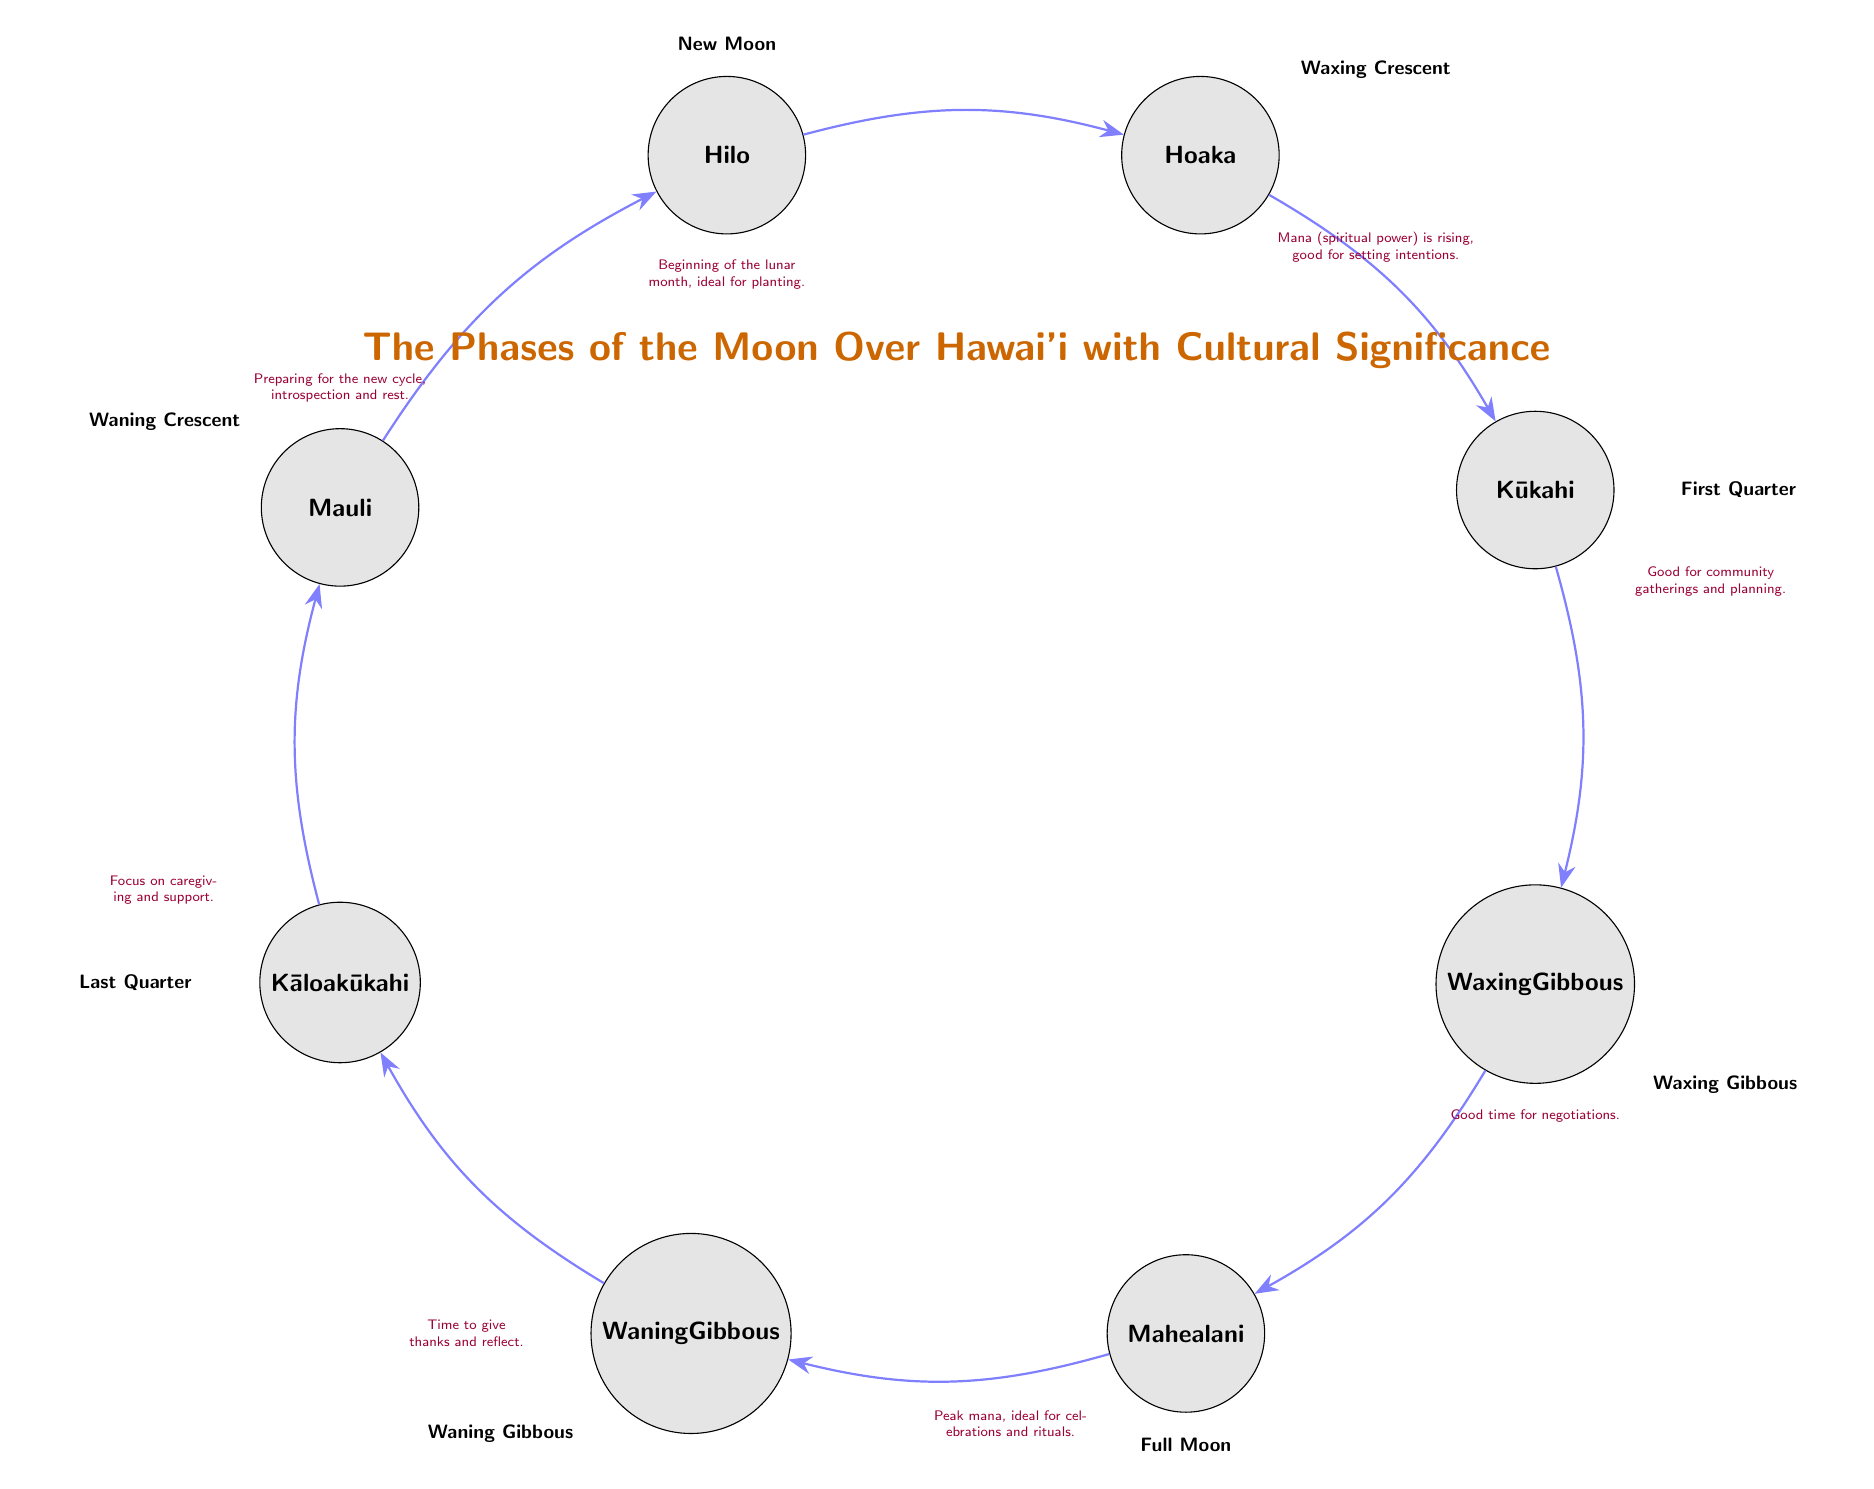What is the first phase of the moon shown in the diagram? The diagram indicates that the first phase is marked as "New Moon." This is the starting point of the phases.
Answer: New Moon Which phase is associated with the term "Mahealani"? The term "Mahealani" is used to represent the Full Moon phase according to the diagram.
Answer: Full Moon What is the second phase of the moon? According to the diagram, the second phase following the New Moon is the Waxing Crescent.
Answer: Waxing Crescent How many phases of the moon are illustrated in the diagram? The diagram illustrates a total of eight phases, including the descriptions provided for each.
Answer: Eight Which phase should one focus on for caregiving and support? The diagram indicates that the Last Quarter phase is designated for caregiving and support, making it the appropriate choice.
Answer: Last Quarter Where does the "Waning Crescent" fall in the order of the moon phases? The Waning Crescent is the last phase before returning to the New Moon, which makes it the eighth phase in the sequence.
Answer: Eighth What cultural aspect is highlighted during the Full Moon phase? The diagram points out that the Full Moon phase is associated with peak mana and is ideal for celebrations and rituals, reflecting cultural significance.
Answer: Peak mana, celebrations, rituals During which phase is it considered a good time for negotiations? According to the diagram, the Waxing Gibbous phase is the time indicated for negotiations, making it the relevant phase for this purpose.
Answer: Waxing Gibbous 